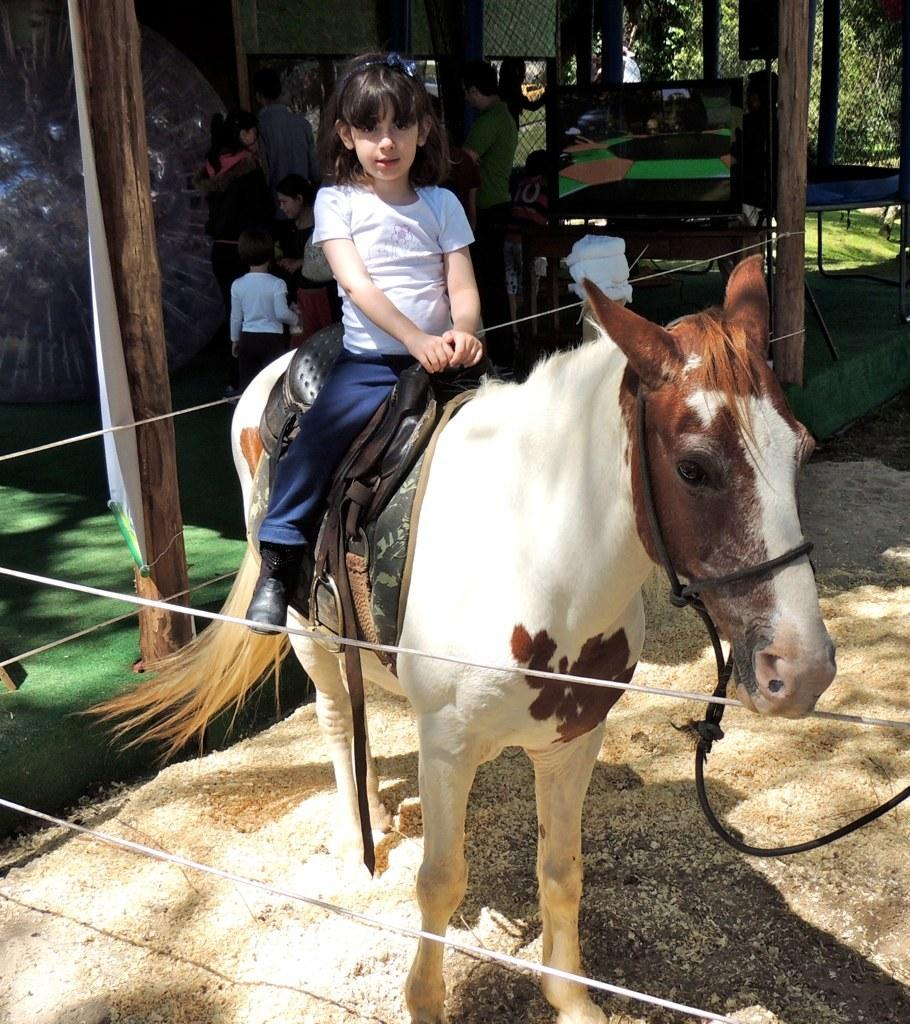What is the girl in the image doing? The girl is riding a horse in the image. What can be seen in the background of the image? There are trees and children visible in the background of the image. What type of vegetation is present in the image? There is bamboo present in the image. What else can be seen in the image besides the girl and the horse? There are cables visible in the image. What caption is written on the island in the image? There is no island present in the image, so there is no caption to be read. 